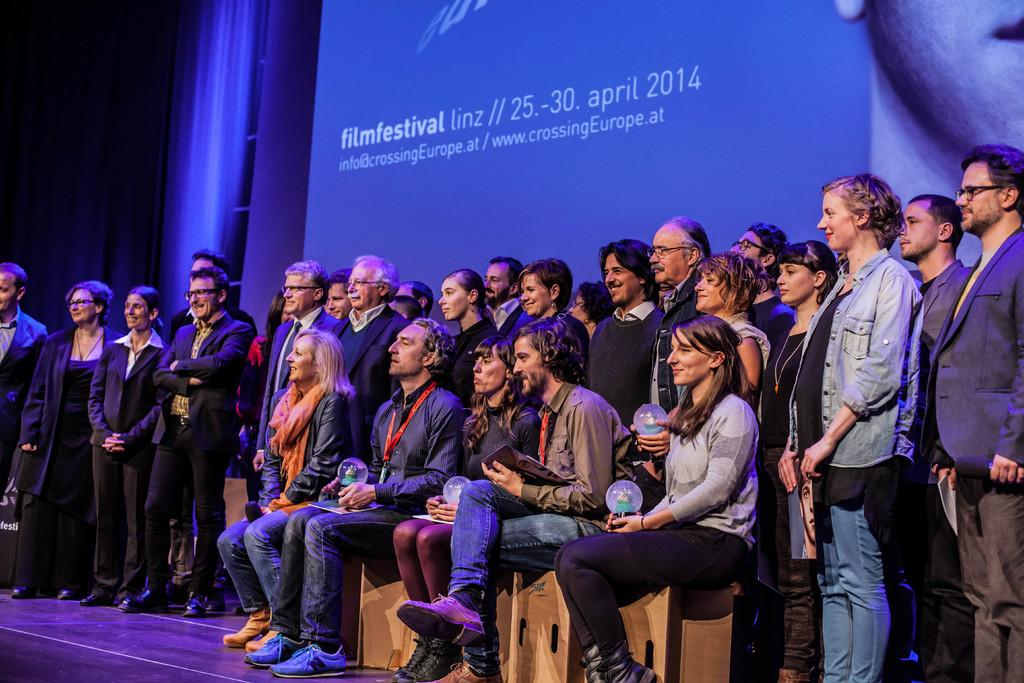What are the persons in the image doing? Some persons are standing on the floor, while others are sitting on seating stools. What can be seen in the background of the image? There is an advertisement and a curtain in the background. What type of eggnog is being served to the governor in the image? There is no governor or eggnog present in the image. What is the governor's wish for the new year in the image? There is no governor or reference to a new year's wish in the image. 